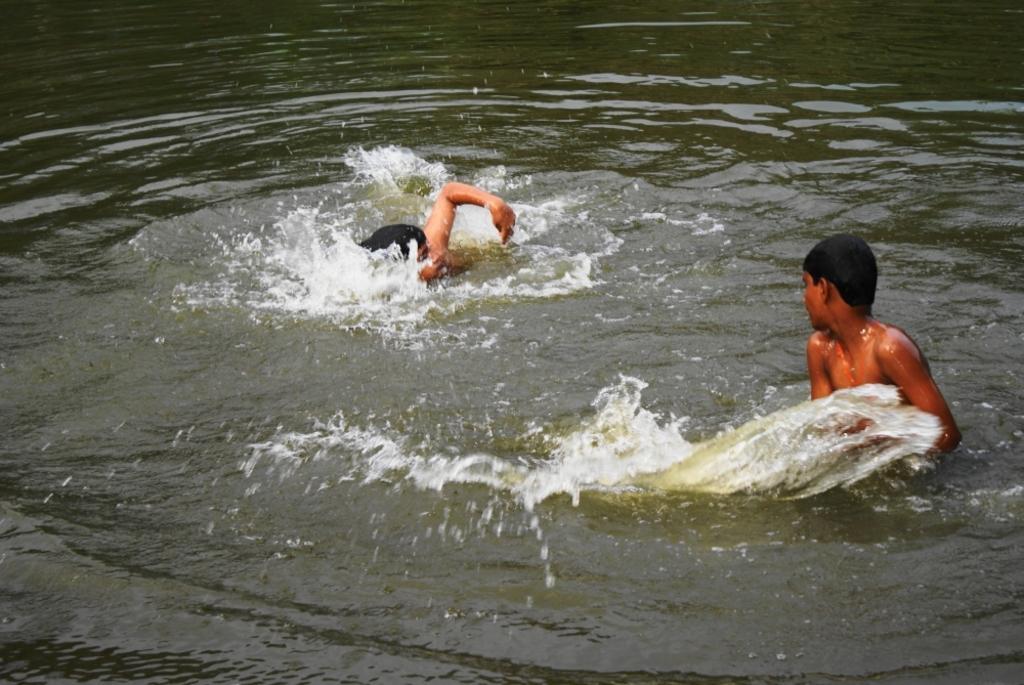How would you summarize this image in a sentence or two? In this image I can see two persons swimming in the water. 